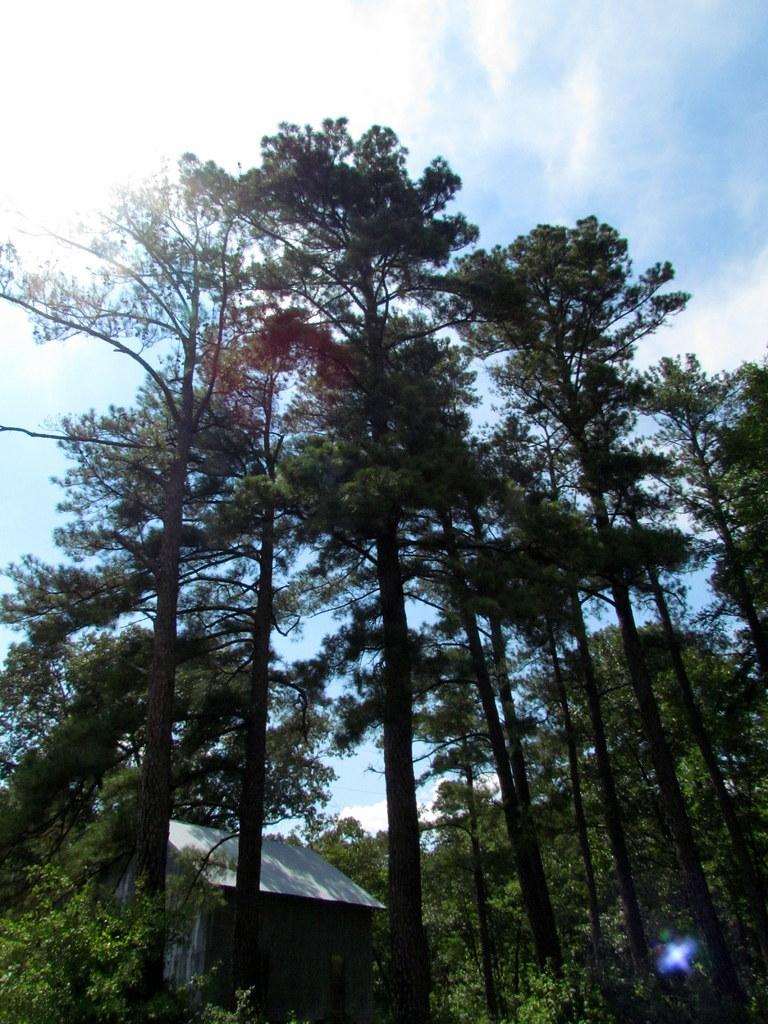What type of natural elements can be seen in the image? There are many trees in the image. What type of man-made structure is present in the image? There is a small building in the image. What is visible in the background of the image? The sky is visible in the background of the image. What can be observed in the sky? Clouds are present in the sky. Who is the creator of the clouds in the image? The clouds in the image are a natural phenomenon and are not created by any individual. Can you see any ongoing war in the image? There is no indication of a war or any conflict in the image. 